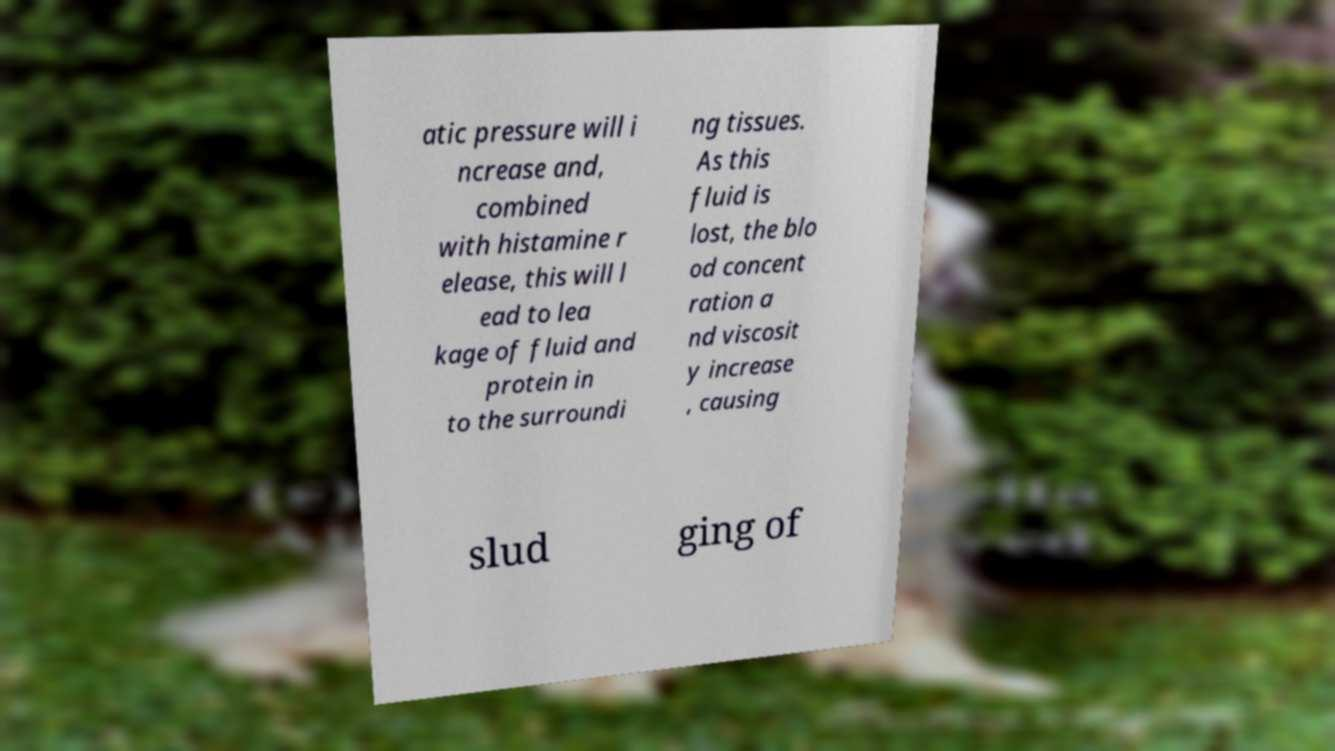Could you extract and type out the text from this image? atic pressure will i ncrease and, combined with histamine r elease, this will l ead to lea kage of fluid and protein in to the surroundi ng tissues. As this fluid is lost, the blo od concent ration a nd viscosit y increase , causing slud ging of 